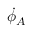Convert formula to latex. <formula><loc_0><loc_0><loc_500><loc_500>{ \dot { \phi } } _ { A }</formula> 